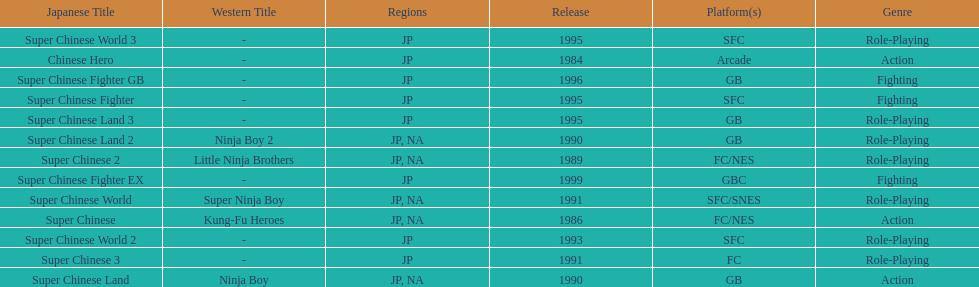What are the total of super chinese games released? 13. 